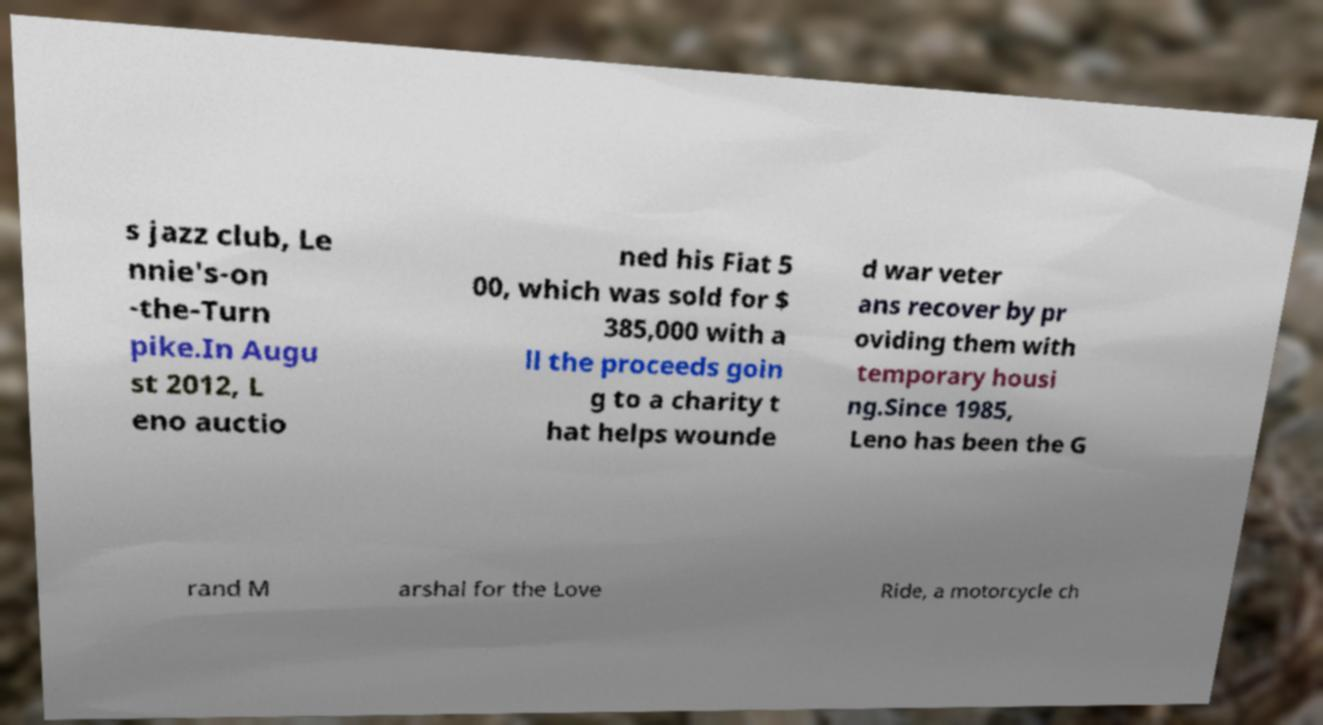There's text embedded in this image that I need extracted. Can you transcribe it verbatim? s jazz club, Le nnie's-on -the-Turn pike.In Augu st 2012, L eno auctio ned his Fiat 5 00, which was sold for $ 385,000 with a ll the proceeds goin g to a charity t hat helps wounde d war veter ans recover by pr oviding them with temporary housi ng.Since 1985, Leno has been the G rand M arshal for the Love Ride, a motorcycle ch 